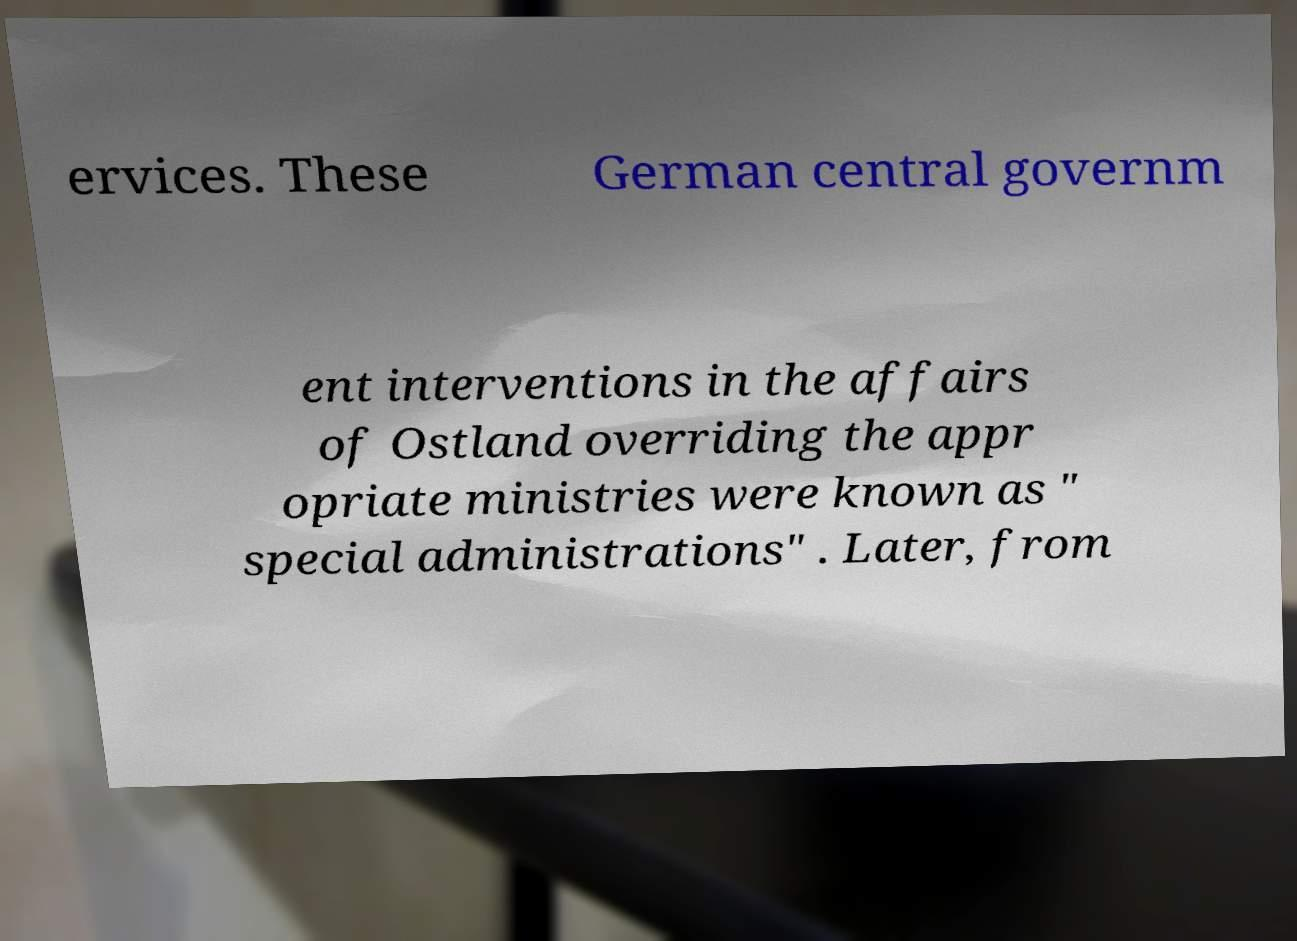Can you read and provide the text displayed in the image?This photo seems to have some interesting text. Can you extract and type it out for me? ervices. These German central governm ent interventions in the affairs of Ostland overriding the appr opriate ministries were known as " special administrations" . Later, from 